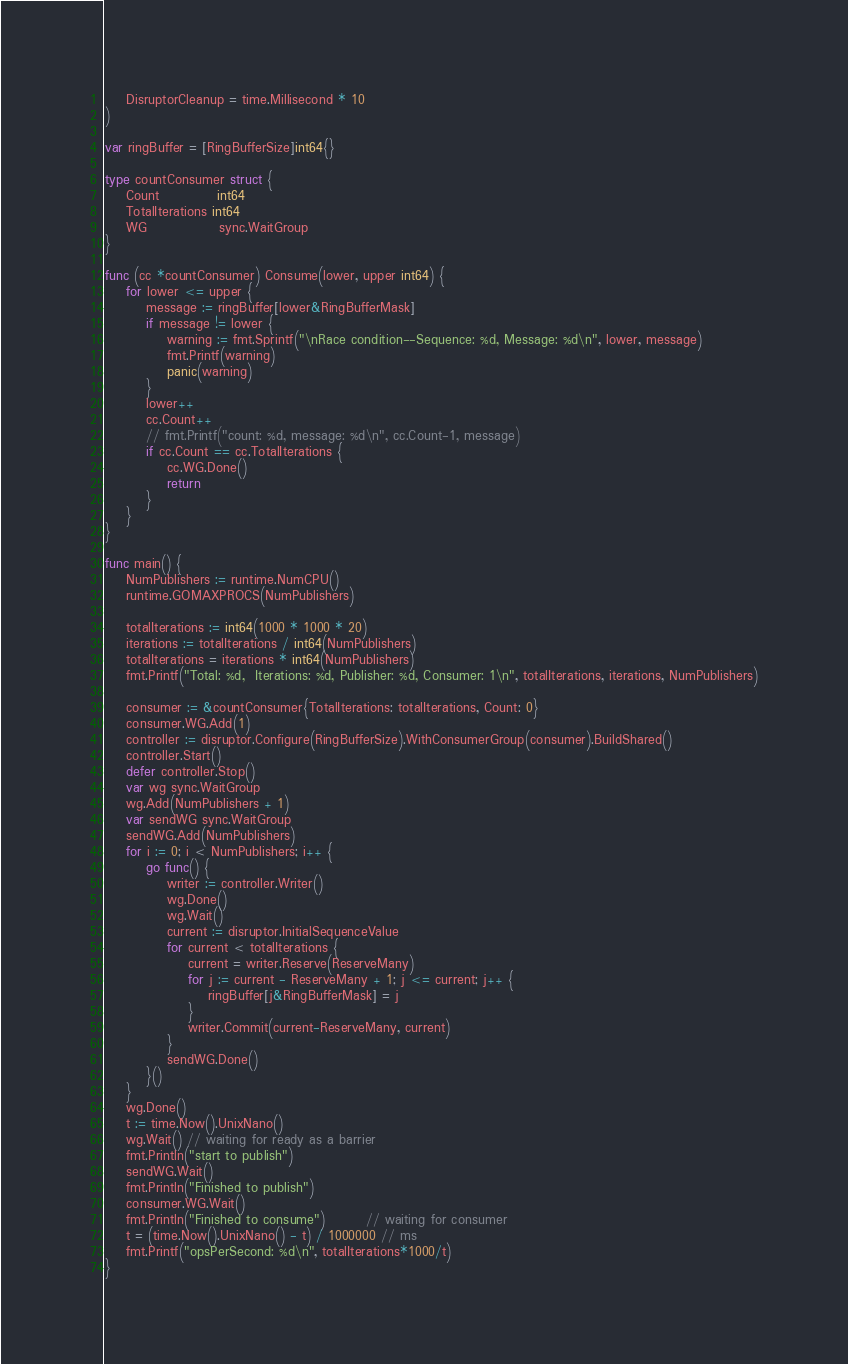Convert code to text. <code><loc_0><loc_0><loc_500><loc_500><_Go_>	DisruptorCleanup = time.Millisecond * 10
)

var ringBuffer = [RingBufferSize]int64{}

type countConsumer struct {
	Count           int64
	TotalIterations int64
	WG              sync.WaitGroup
}

func (cc *countConsumer) Consume(lower, upper int64) {
	for lower <= upper {
		message := ringBuffer[lower&RingBufferMask]
		if message != lower {
			warning := fmt.Sprintf("\nRace condition--Sequence: %d, Message: %d\n", lower, message)
			fmt.Printf(warning)
			panic(warning)
		}
		lower++
		cc.Count++
		// fmt.Printf("count: %d, message: %d\n", cc.Count-1, message)
		if cc.Count == cc.TotalIterations {
			cc.WG.Done()
			return
		}
	}
}

func main() {
	NumPublishers := runtime.NumCPU()
	runtime.GOMAXPROCS(NumPublishers)

	totalIterations := int64(1000 * 1000 * 20)
	iterations := totalIterations / int64(NumPublishers)
	totalIterations = iterations * int64(NumPublishers)
	fmt.Printf("Total: %d,  Iterations: %d, Publisher: %d, Consumer: 1\n", totalIterations, iterations, NumPublishers)

	consumer := &countConsumer{TotalIterations: totalIterations, Count: 0}
	consumer.WG.Add(1)
	controller := disruptor.Configure(RingBufferSize).WithConsumerGroup(consumer).BuildShared()
	controller.Start()
	defer controller.Stop()
	var wg sync.WaitGroup
	wg.Add(NumPublishers + 1)
	var sendWG sync.WaitGroup
	sendWG.Add(NumPublishers)
	for i := 0; i < NumPublishers; i++ {
		go func() {
			writer := controller.Writer()
			wg.Done()
			wg.Wait()
			current := disruptor.InitialSequenceValue
			for current < totalIterations {
				current = writer.Reserve(ReserveMany)
				for j := current - ReserveMany + 1; j <= current; j++ {
					ringBuffer[j&RingBufferMask] = j
				}
				writer.Commit(current-ReserveMany, current)
			}
			sendWG.Done()
		}()
	}
	wg.Done()
	t := time.Now().UnixNano()
	wg.Wait() // waiting for ready as a barrier
	fmt.Println("start to publish")
	sendWG.Wait()
	fmt.Println("Finished to publish")
	consumer.WG.Wait()
	fmt.Println("Finished to consume")        // waiting for consumer
	t = (time.Now().UnixNano() - t) / 1000000 // ms
	fmt.Printf("opsPerSecond: %d\n", totalIterations*1000/t)
}
</code> 